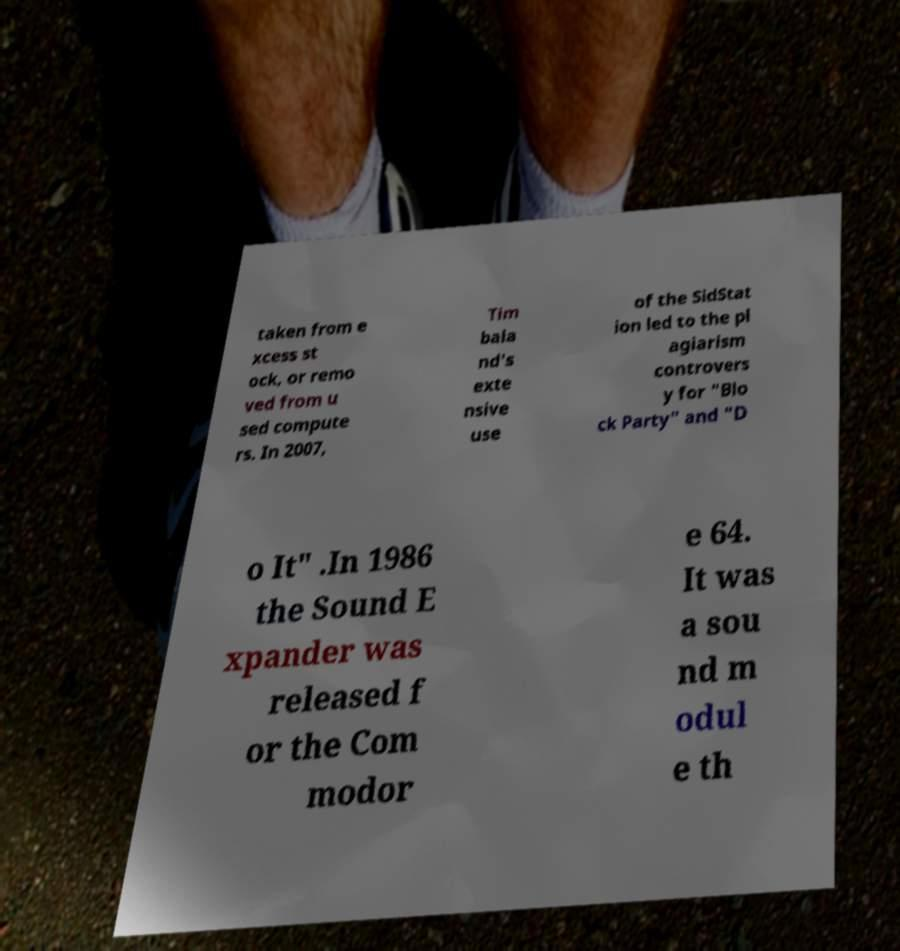I need the written content from this picture converted into text. Can you do that? taken from e xcess st ock, or remo ved from u sed compute rs. In 2007, Tim bala nd's exte nsive use of the SidStat ion led to the pl agiarism controvers y for "Blo ck Party" and "D o It" .In 1986 the Sound E xpander was released f or the Com modor e 64. It was a sou nd m odul e th 